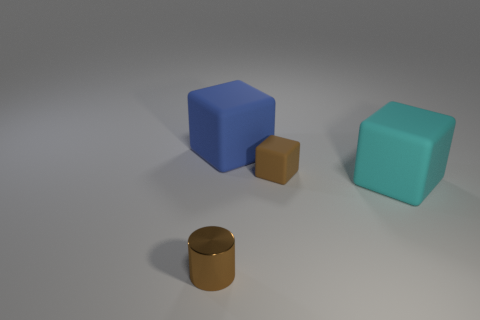What is the color of the object that is in front of the large blue thing and to the left of the small brown rubber cube? The object located in front of the large blue cube and to the left of the small brown cube is brown. However, to provide a bit more detail, it's a cylindrical-shaped container with a metallic sheen, suggesting it might be made of metal or a similar material. 